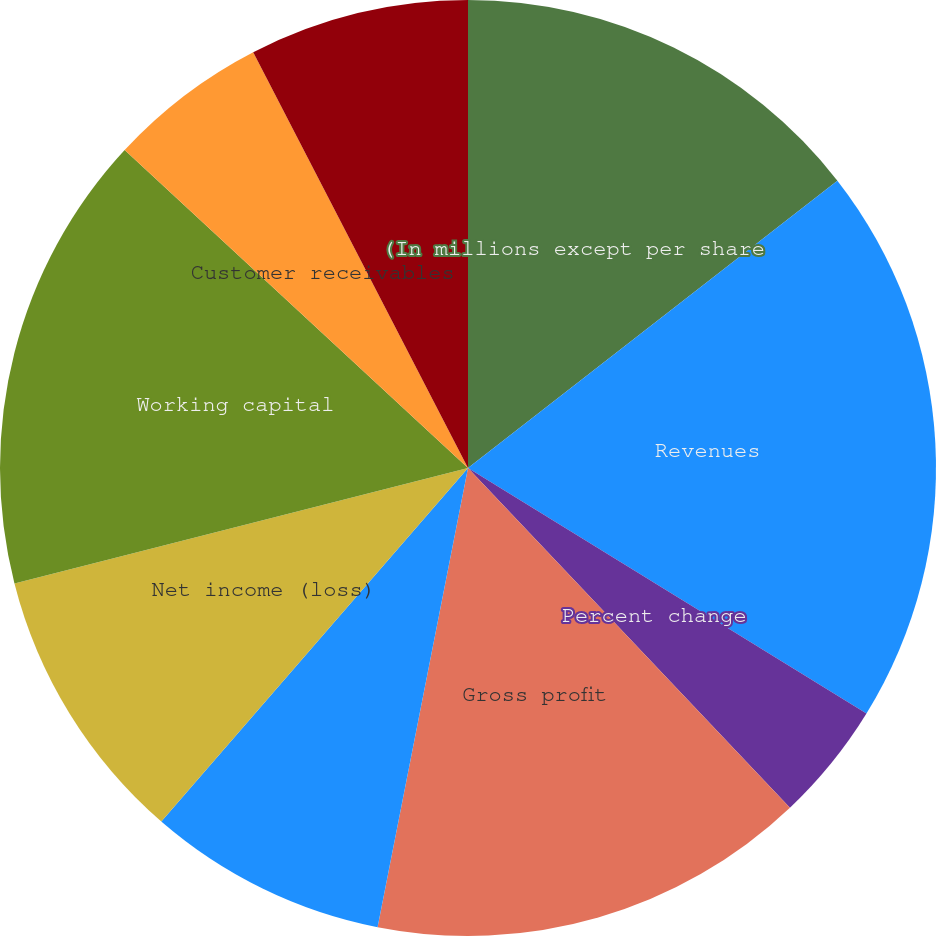Convert chart. <chart><loc_0><loc_0><loc_500><loc_500><pie_chart><fcel>(In millions except per share<fcel>Revenues<fcel>Percent change<fcel>Gross profit<fcel>Income (loss) from continuing<fcel>Net income (loss)<fcel>Working capital<fcel>Customer receivables<fcel>Inventories<nl><fcel>14.48%<fcel>19.31%<fcel>4.14%<fcel>15.17%<fcel>8.28%<fcel>9.66%<fcel>15.86%<fcel>5.52%<fcel>7.59%<nl></chart> 